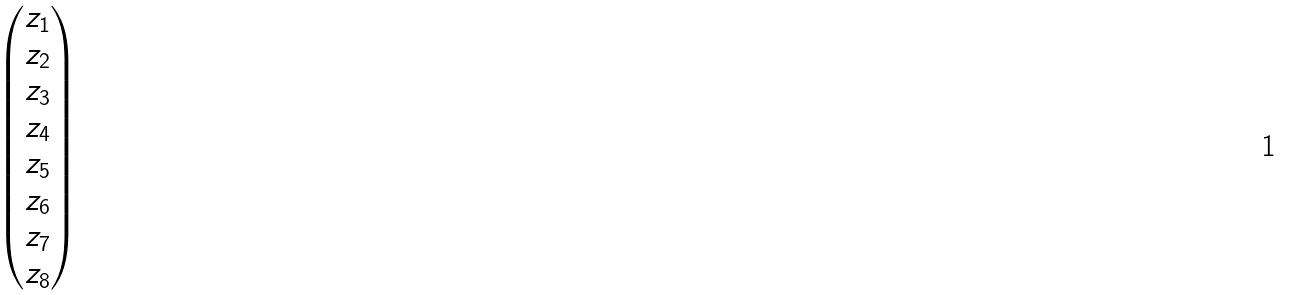<formula> <loc_0><loc_0><loc_500><loc_500>\begin{pmatrix} z _ { 1 } \\ z _ { 2 } \\ z _ { 3 } \\ z _ { 4 } \\ z _ { 5 } \\ z _ { 6 } \\ z _ { 7 } \\ z _ { 8 } \end{pmatrix}</formula> 